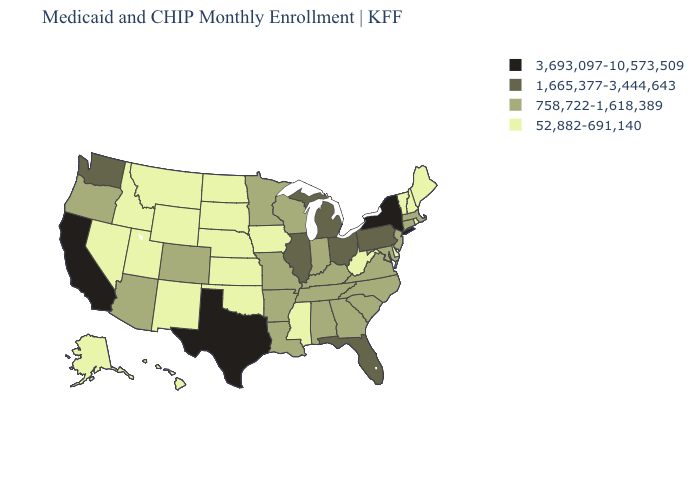Does Alabama have a lower value than Connecticut?
Quick response, please. No. What is the highest value in states that border Kansas?
Give a very brief answer. 758,722-1,618,389. Does the map have missing data?
Short answer required. No. What is the value of West Virginia?
Keep it brief. 52,882-691,140. Name the states that have a value in the range 52,882-691,140?
Keep it brief. Alaska, Delaware, Hawaii, Idaho, Iowa, Kansas, Maine, Mississippi, Montana, Nebraska, Nevada, New Hampshire, New Mexico, North Dakota, Oklahoma, Rhode Island, South Dakota, Utah, Vermont, West Virginia, Wyoming. What is the value of Tennessee?
Be succinct. 758,722-1,618,389. Does Idaho have the same value as Washington?
Short answer required. No. What is the value of New Jersey?
Quick response, please. 758,722-1,618,389. What is the value of Utah?
Answer briefly. 52,882-691,140. Does Oregon have the lowest value in the USA?
Quick response, please. No. Name the states that have a value in the range 3,693,097-10,573,509?
Short answer required. California, New York, Texas. What is the highest value in the Northeast ?
Give a very brief answer. 3,693,097-10,573,509. Which states have the lowest value in the USA?
Keep it brief. Alaska, Delaware, Hawaii, Idaho, Iowa, Kansas, Maine, Mississippi, Montana, Nebraska, Nevada, New Hampshire, New Mexico, North Dakota, Oklahoma, Rhode Island, South Dakota, Utah, Vermont, West Virginia, Wyoming. What is the highest value in the South ?
Give a very brief answer. 3,693,097-10,573,509. 